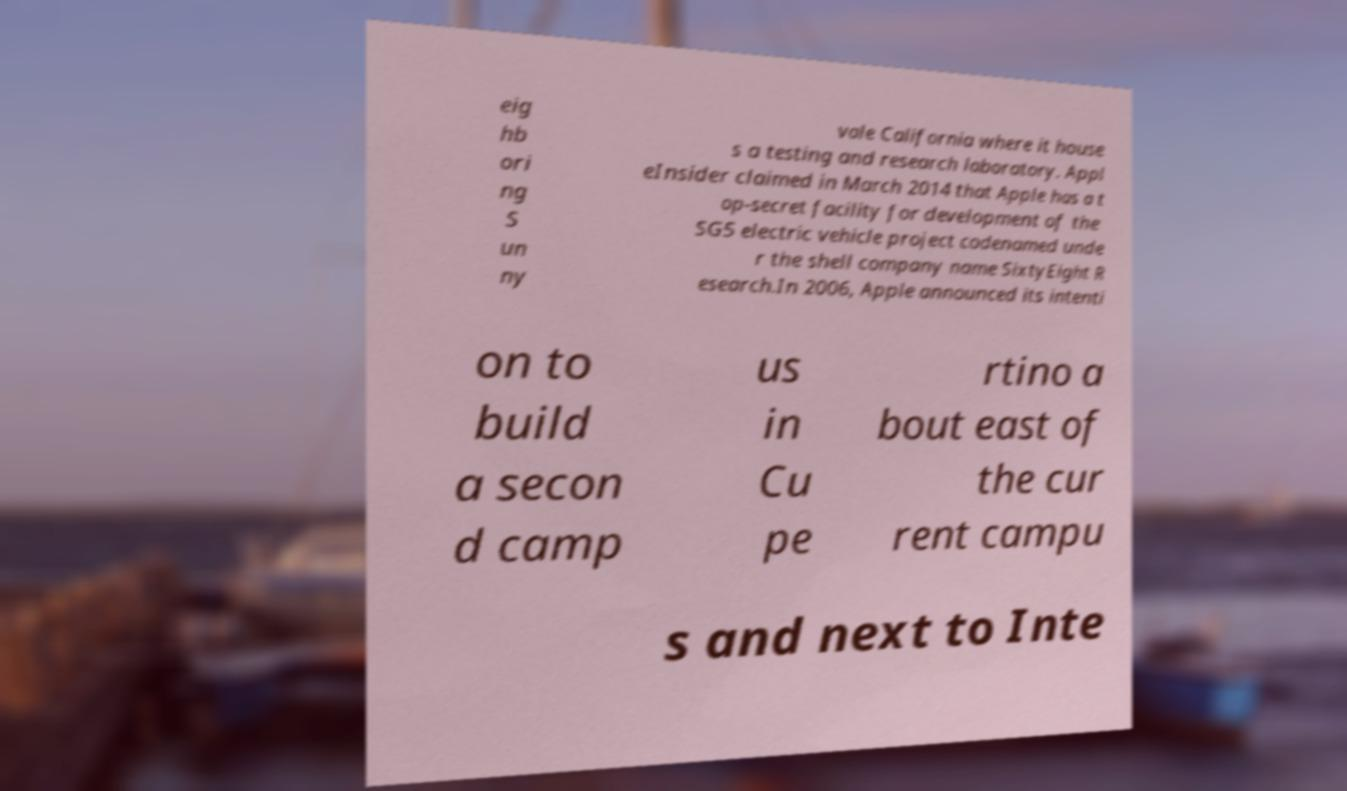Please identify and transcribe the text found in this image. eig hb ori ng S un ny vale California where it house s a testing and research laboratory. Appl eInsider claimed in March 2014 that Apple has a t op-secret facility for development of the SG5 electric vehicle project codenamed unde r the shell company name SixtyEight R esearch.In 2006, Apple announced its intenti on to build a secon d camp us in Cu pe rtino a bout east of the cur rent campu s and next to Inte 